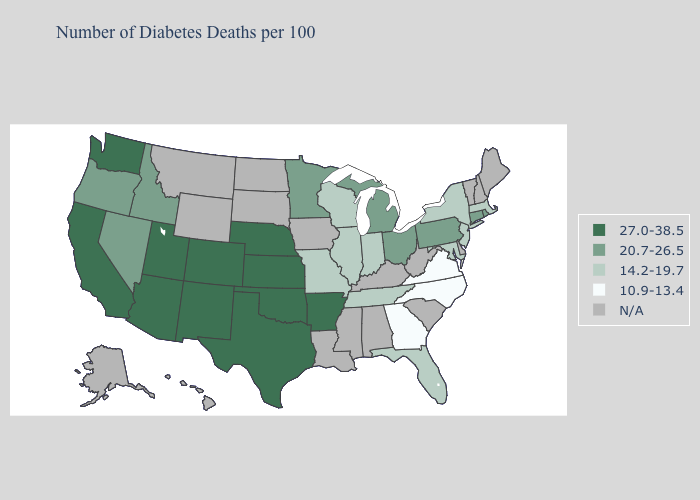How many symbols are there in the legend?
Concise answer only. 5. Name the states that have a value in the range 27.0-38.5?
Write a very short answer. Arizona, Arkansas, California, Colorado, Kansas, Nebraska, New Mexico, Oklahoma, Texas, Utah, Washington. Does the map have missing data?
Concise answer only. Yes. Name the states that have a value in the range N/A?
Quick response, please. Alabama, Alaska, Delaware, Hawaii, Iowa, Kentucky, Louisiana, Maine, Mississippi, Montana, New Hampshire, North Dakota, South Carolina, South Dakota, Vermont, West Virginia, Wyoming. Which states have the highest value in the USA?
Concise answer only. Arizona, Arkansas, California, Colorado, Kansas, Nebraska, New Mexico, Oklahoma, Texas, Utah, Washington. Name the states that have a value in the range 10.9-13.4?
Be succinct. Georgia, North Carolina, Virginia. Among the states that border New Hampshire , which have the highest value?
Give a very brief answer. Massachusetts. Which states have the highest value in the USA?
Quick response, please. Arizona, Arkansas, California, Colorado, Kansas, Nebraska, New Mexico, Oklahoma, Texas, Utah, Washington. What is the value of Iowa?
Be succinct. N/A. Does the first symbol in the legend represent the smallest category?
Concise answer only. No. Among the states that border Pennsylvania , which have the highest value?
Short answer required. Ohio. How many symbols are there in the legend?
Give a very brief answer. 5. What is the highest value in the USA?
Concise answer only. 27.0-38.5. What is the value of Connecticut?
Keep it brief. 20.7-26.5. 